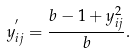<formula> <loc_0><loc_0><loc_500><loc_500>y _ { i j } ^ { ^ { \prime } } = \frac { b - 1 + y _ { i j } ^ { 2 } } { b } .</formula> 